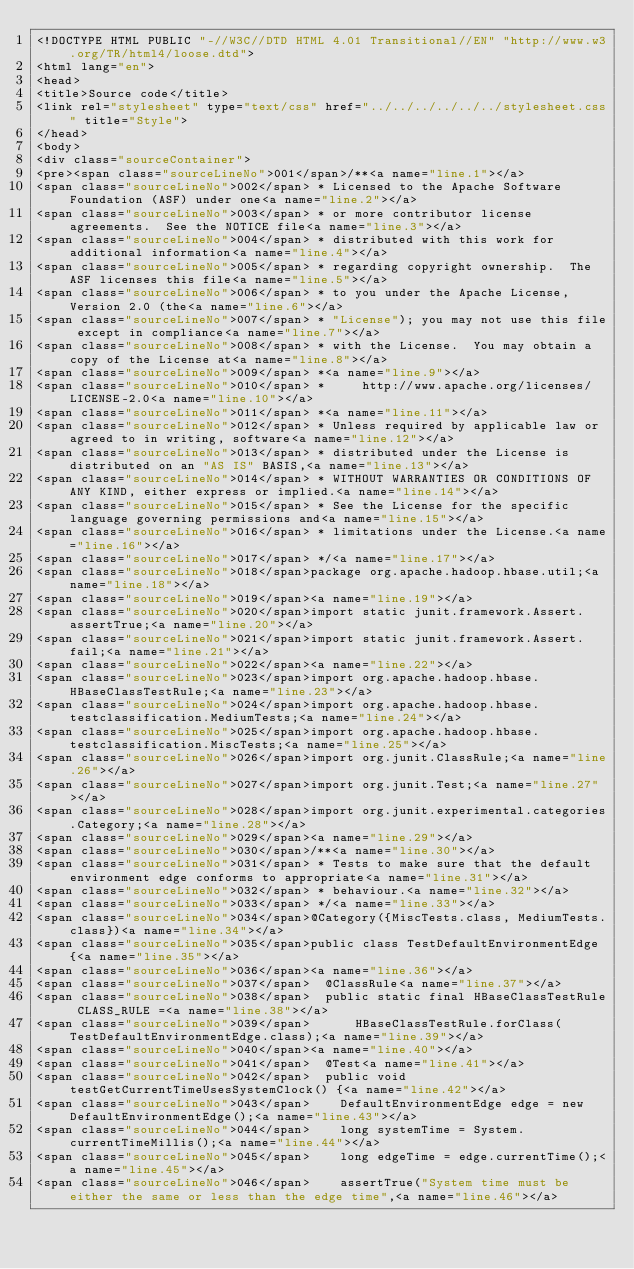Convert code to text. <code><loc_0><loc_0><loc_500><loc_500><_HTML_><!DOCTYPE HTML PUBLIC "-//W3C//DTD HTML 4.01 Transitional//EN" "http://www.w3.org/TR/html4/loose.dtd">
<html lang="en">
<head>
<title>Source code</title>
<link rel="stylesheet" type="text/css" href="../../../../../../stylesheet.css" title="Style">
</head>
<body>
<div class="sourceContainer">
<pre><span class="sourceLineNo">001</span>/**<a name="line.1"></a>
<span class="sourceLineNo">002</span> * Licensed to the Apache Software Foundation (ASF) under one<a name="line.2"></a>
<span class="sourceLineNo">003</span> * or more contributor license agreements.  See the NOTICE file<a name="line.3"></a>
<span class="sourceLineNo">004</span> * distributed with this work for additional information<a name="line.4"></a>
<span class="sourceLineNo">005</span> * regarding copyright ownership.  The ASF licenses this file<a name="line.5"></a>
<span class="sourceLineNo">006</span> * to you under the Apache License, Version 2.0 (the<a name="line.6"></a>
<span class="sourceLineNo">007</span> * "License"); you may not use this file except in compliance<a name="line.7"></a>
<span class="sourceLineNo">008</span> * with the License.  You may obtain a copy of the License at<a name="line.8"></a>
<span class="sourceLineNo">009</span> *<a name="line.9"></a>
<span class="sourceLineNo">010</span> *     http://www.apache.org/licenses/LICENSE-2.0<a name="line.10"></a>
<span class="sourceLineNo">011</span> *<a name="line.11"></a>
<span class="sourceLineNo">012</span> * Unless required by applicable law or agreed to in writing, software<a name="line.12"></a>
<span class="sourceLineNo">013</span> * distributed under the License is distributed on an "AS IS" BASIS,<a name="line.13"></a>
<span class="sourceLineNo">014</span> * WITHOUT WARRANTIES OR CONDITIONS OF ANY KIND, either express or implied.<a name="line.14"></a>
<span class="sourceLineNo">015</span> * See the License for the specific language governing permissions and<a name="line.15"></a>
<span class="sourceLineNo">016</span> * limitations under the License.<a name="line.16"></a>
<span class="sourceLineNo">017</span> */<a name="line.17"></a>
<span class="sourceLineNo">018</span>package org.apache.hadoop.hbase.util;<a name="line.18"></a>
<span class="sourceLineNo">019</span><a name="line.19"></a>
<span class="sourceLineNo">020</span>import static junit.framework.Assert.assertTrue;<a name="line.20"></a>
<span class="sourceLineNo">021</span>import static junit.framework.Assert.fail;<a name="line.21"></a>
<span class="sourceLineNo">022</span><a name="line.22"></a>
<span class="sourceLineNo">023</span>import org.apache.hadoop.hbase.HBaseClassTestRule;<a name="line.23"></a>
<span class="sourceLineNo">024</span>import org.apache.hadoop.hbase.testclassification.MediumTests;<a name="line.24"></a>
<span class="sourceLineNo">025</span>import org.apache.hadoop.hbase.testclassification.MiscTests;<a name="line.25"></a>
<span class="sourceLineNo">026</span>import org.junit.ClassRule;<a name="line.26"></a>
<span class="sourceLineNo">027</span>import org.junit.Test;<a name="line.27"></a>
<span class="sourceLineNo">028</span>import org.junit.experimental.categories.Category;<a name="line.28"></a>
<span class="sourceLineNo">029</span><a name="line.29"></a>
<span class="sourceLineNo">030</span>/**<a name="line.30"></a>
<span class="sourceLineNo">031</span> * Tests to make sure that the default environment edge conforms to appropriate<a name="line.31"></a>
<span class="sourceLineNo">032</span> * behaviour.<a name="line.32"></a>
<span class="sourceLineNo">033</span> */<a name="line.33"></a>
<span class="sourceLineNo">034</span>@Category({MiscTests.class, MediumTests.class})<a name="line.34"></a>
<span class="sourceLineNo">035</span>public class TestDefaultEnvironmentEdge {<a name="line.35"></a>
<span class="sourceLineNo">036</span><a name="line.36"></a>
<span class="sourceLineNo">037</span>  @ClassRule<a name="line.37"></a>
<span class="sourceLineNo">038</span>  public static final HBaseClassTestRule CLASS_RULE =<a name="line.38"></a>
<span class="sourceLineNo">039</span>      HBaseClassTestRule.forClass(TestDefaultEnvironmentEdge.class);<a name="line.39"></a>
<span class="sourceLineNo">040</span><a name="line.40"></a>
<span class="sourceLineNo">041</span>  @Test<a name="line.41"></a>
<span class="sourceLineNo">042</span>  public void testGetCurrentTimeUsesSystemClock() {<a name="line.42"></a>
<span class="sourceLineNo">043</span>    DefaultEnvironmentEdge edge = new DefaultEnvironmentEdge();<a name="line.43"></a>
<span class="sourceLineNo">044</span>    long systemTime = System.currentTimeMillis();<a name="line.44"></a>
<span class="sourceLineNo">045</span>    long edgeTime = edge.currentTime();<a name="line.45"></a>
<span class="sourceLineNo">046</span>    assertTrue("System time must be either the same or less than the edge time",<a name="line.46"></a></code> 